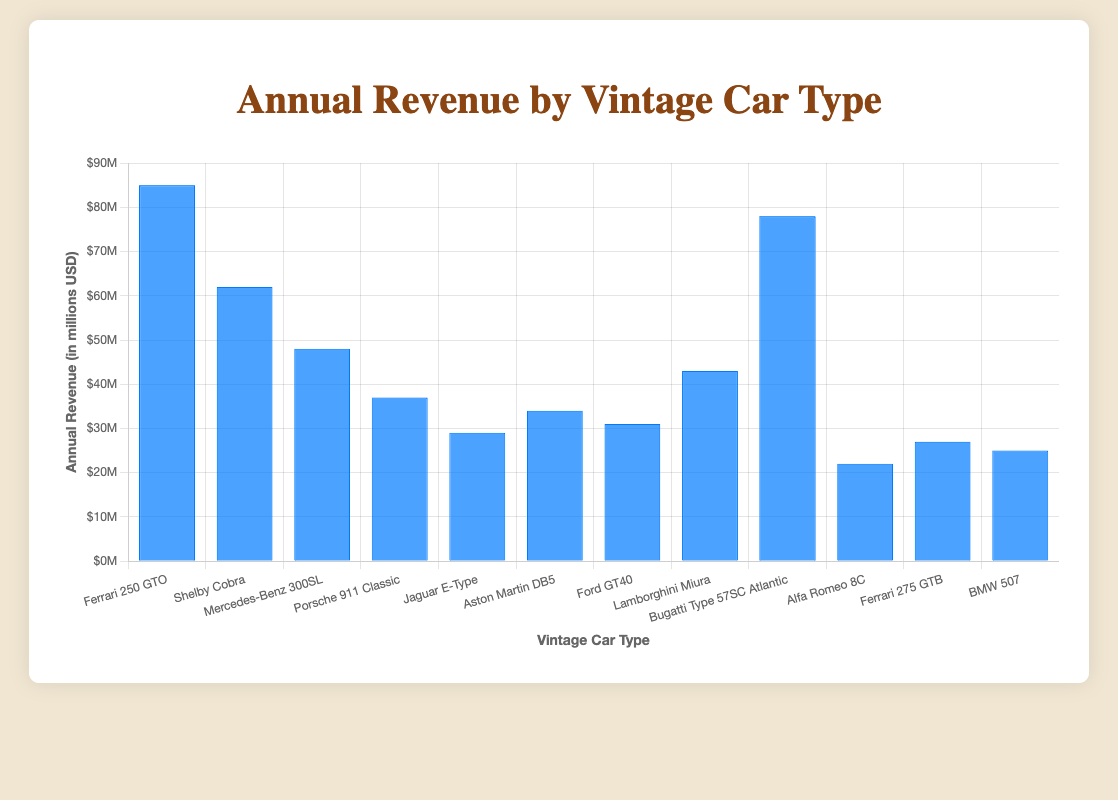Which vintage car type generated the highest annual revenue? The figure shows each car type with its respective annual revenue. The Ferrari 250 GTO bar is the highest on the chart, indicating it has the highest revenue.
Answer: Ferrari 250 GTO How much more annual revenue did the Ferrari 250 GTO generate compared to the Alfa Romeo 8C? The annual revenue for the Ferrari 250 GTO is $85 million, and for the Alfa Romeo 8C, it's $22 million. The difference is $85 million - $22 million = $63 million.
Answer: $63 million What is the total annual revenue generated by the Ferrari 250 GTO, Shelby Cobra, and Bugatti Type 57SC Atlantic combined? Adding the revenues for these three cars: Ferrari 250 GTO ($85 million) + Shelby Cobra ($62 million) + Bugatti Type 57SC Atlantic ($78 million) = $225 million.
Answer: $225 million Which car type generated less revenue: Porsche 911 Classic or Aston Martin DB5, and by how much? The annual revenue for Porsche 911 Classic is $37 million and for Aston Martin DB5 is $34 million. The Porsche 911 Classic generated $37 million - $34 million = $3 million more.
Answer: Aston Martin DB5 by $3 million Among the listed car types, what is the average annual revenue? Sum of all revenues: $85M + $62M + $48M + $37M + $29M + $34M + $31M + $43M + $78M + $22M + $27M + $25M = $521 million. There are 12 car types. The average is $521 million / 12 = $43.42 million.
Answer: $43.42 million Which car type has a revenue closest to the average annual revenue of all car types listed? The average revenue is approximately $43.42 million. The Lamborghini Miura is closest to this with an annual revenue of $43 million.
Answer: Lamborghini Miura Arrange the top three car types by annual revenue in descending order. The top three car types with the highest revenues are Ferrari 250 GTO ($85 million), Bugatti Type 57SC Atlantic ($78 million), and Shelby Cobra ($62 million).
Answer: Ferrari 250 GTO, Bugatti Type 57SC Atlantic, Shelby Cobra What is the combined revenue of the lowest three earning car types? The three cars with the lowest revenues are Alfa Romeo 8C ($22 million), BMW 507 ($25 million), and Ferrari 275 GTB ($27 million). Their combined revenue is $22M + $25M + $27M = $74 million.
Answer: $74 million By how much does the annual revenue of Mercedes-Benz 300SL exceed the revenue of BMW 507? Mercedes-Benz 300SL has a revenue of $48 million, while BMW 507 has $25 million. The difference is $48 million - $25 million = $23 million.
Answer: $23 million 